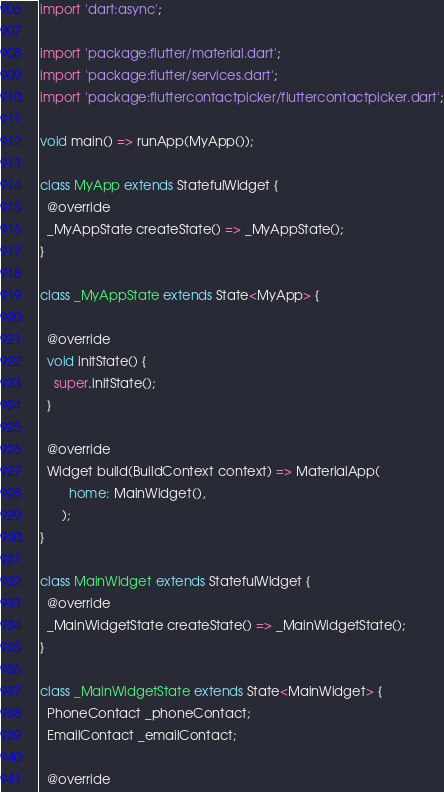Convert code to text. <code><loc_0><loc_0><loc_500><loc_500><_Dart_>import 'dart:async';

import 'package:flutter/material.dart';
import 'package:flutter/services.dart';
import 'package:fluttercontactpicker/fluttercontactpicker.dart';

void main() => runApp(MyApp());

class MyApp extends StatefulWidget {
  @override
  _MyAppState createState() => _MyAppState();
}

class _MyAppState extends State<MyApp> {

  @override
  void initState() {
    super.initState();
  }

  @override
  Widget build(BuildContext context) => MaterialApp(
        home: MainWidget(),
      );
}

class MainWidget extends StatefulWidget {
  @override
  _MainWidgetState createState() => _MainWidgetState();
}

class _MainWidgetState extends State<MainWidget> {
  PhoneContact _phoneContact;
  EmailContact _emailContact;

  @override</code> 